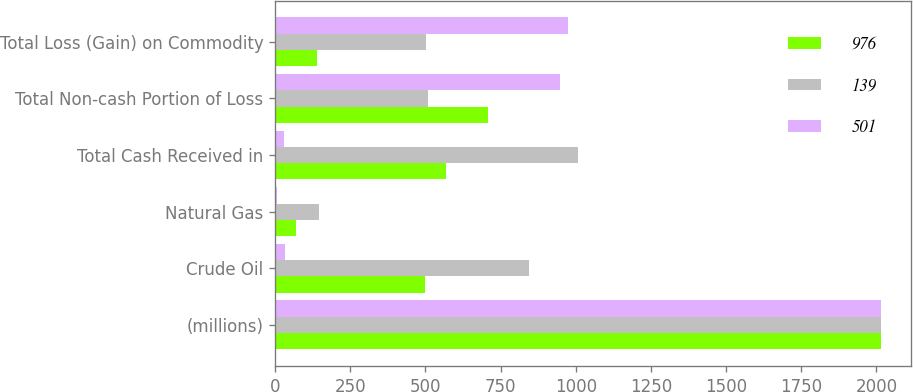<chart> <loc_0><loc_0><loc_500><loc_500><stacked_bar_chart><ecel><fcel>(millions)<fcel>Crude Oil<fcel>Natural Gas<fcel>Total Cash Received in<fcel>Total Non-cash Portion of Loss<fcel>Total Loss (Gain) on Commodity<nl><fcel>976<fcel>2016<fcel>499<fcel>70<fcel>569<fcel>708<fcel>139<nl><fcel>139<fcel>2015<fcel>844<fcel>147<fcel>1009<fcel>508<fcel>501<nl><fcel>501<fcel>2014<fcel>34<fcel>5<fcel>29<fcel>947<fcel>976<nl></chart> 